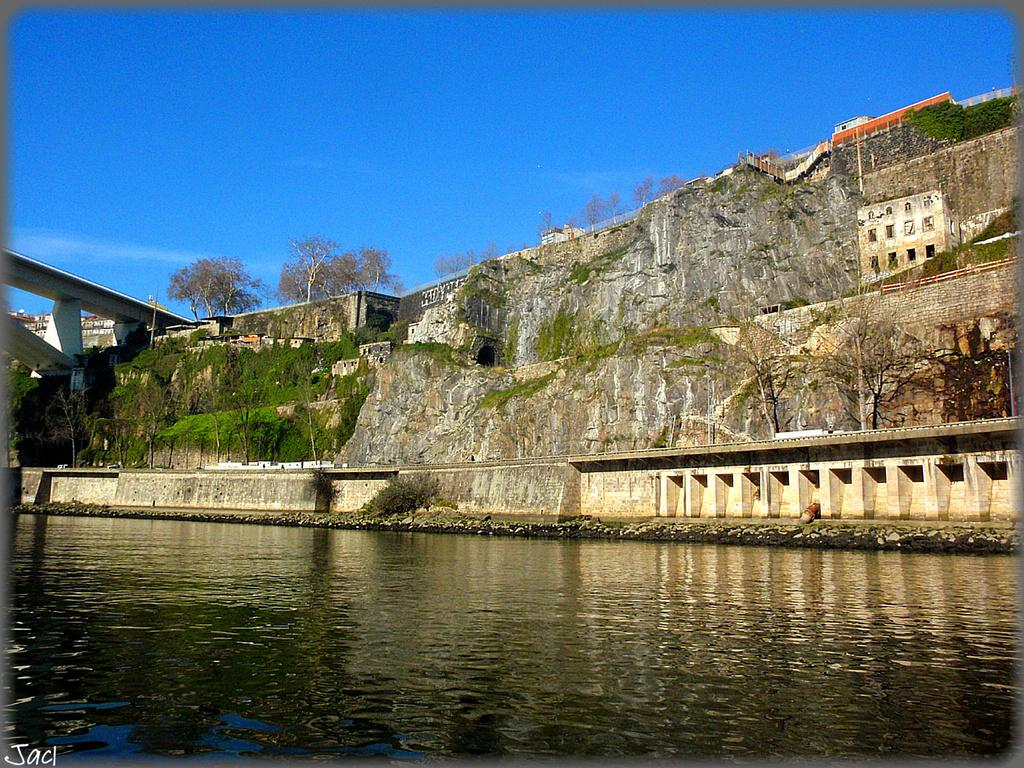What type of natural landscape can be seen in the image? There are hills in the image. What type of vegetation is present in the image? There are trees in the image. What type of man-made structures are visible in the image? There are buildings and a wall in the image. What type of transportation is present in the image? There are vehicles in the image. What type of architectural feature is present in the image? There is a bridge in the image. What type of text can be seen in the image? There is text visible in the image. What type of natural element is visible in the image? There is water visible in the image. What type of sky condition is visible in the image? There is sky visible in the image, and there are clouds visible in the image. What type of song is being played on the gold scale in the image? There is no song or gold scale present in the image. What type of gold object is visible in the image? There is no gold object present in the image. 